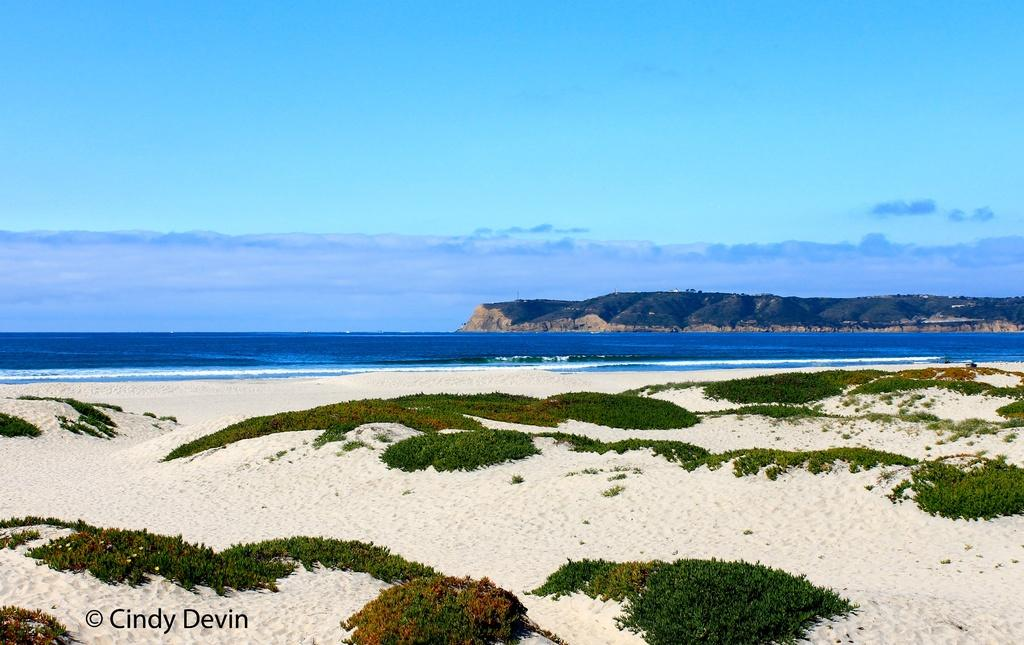What type of terrain is visible in the image? There is sand in the image. What other natural elements can be seen in the image? There are plants and a sea in the background of the image. What other geographical features are visible in the background? There is a mountain in the background of the image. What part of the sky is visible in the image? The sky is visible in the background of the image. Is there any text present in the image? Yes, there is text in the bottom left corner of the image. What is the income of the plants in the image? There is no income associated with the plants in the image, as they are not living beings capable of earning money. 